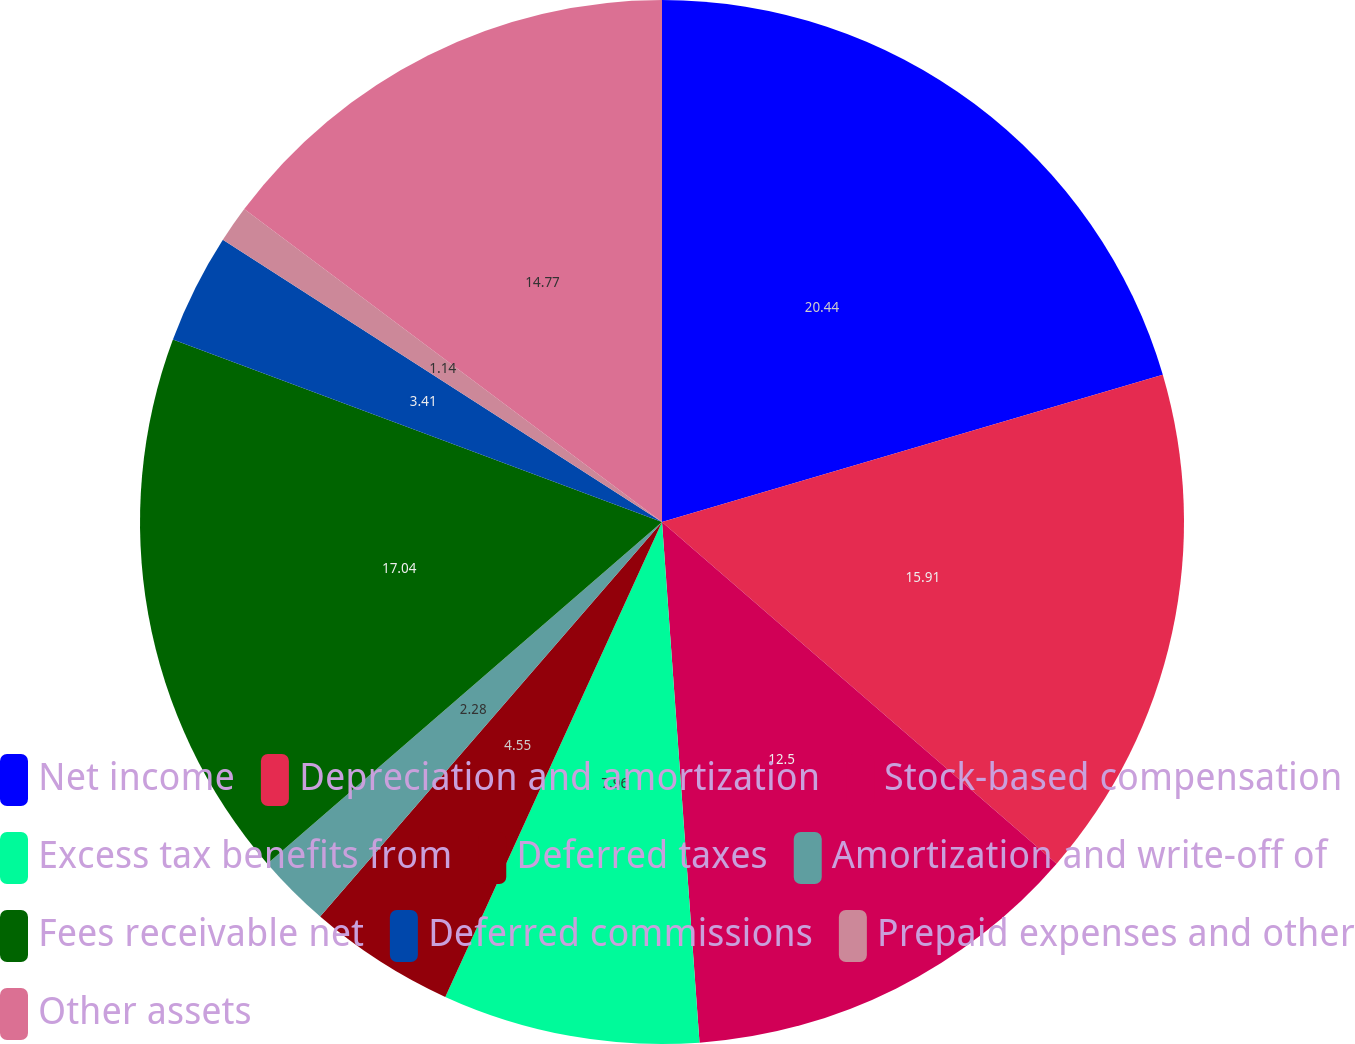Convert chart. <chart><loc_0><loc_0><loc_500><loc_500><pie_chart><fcel>Net income<fcel>Depreciation and amortization<fcel>Stock-based compensation<fcel>Excess tax benefits from<fcel>Deferred taxes<fcel>Amortization and write-off of<fcel>Fees receivable net<fcel>Deferred commissions<fcel>Prepaid expenses and other<fcel>Other assets<nl><fcel>20.45%<fcel>15.91%<fcel>12.5%<fcel>7.96%<fcel>4.55%<fcel>2.28%<fcel>17.04%<fcel>3.41%<fcel>1.14%<fcel>14.77%<nl></chart> 